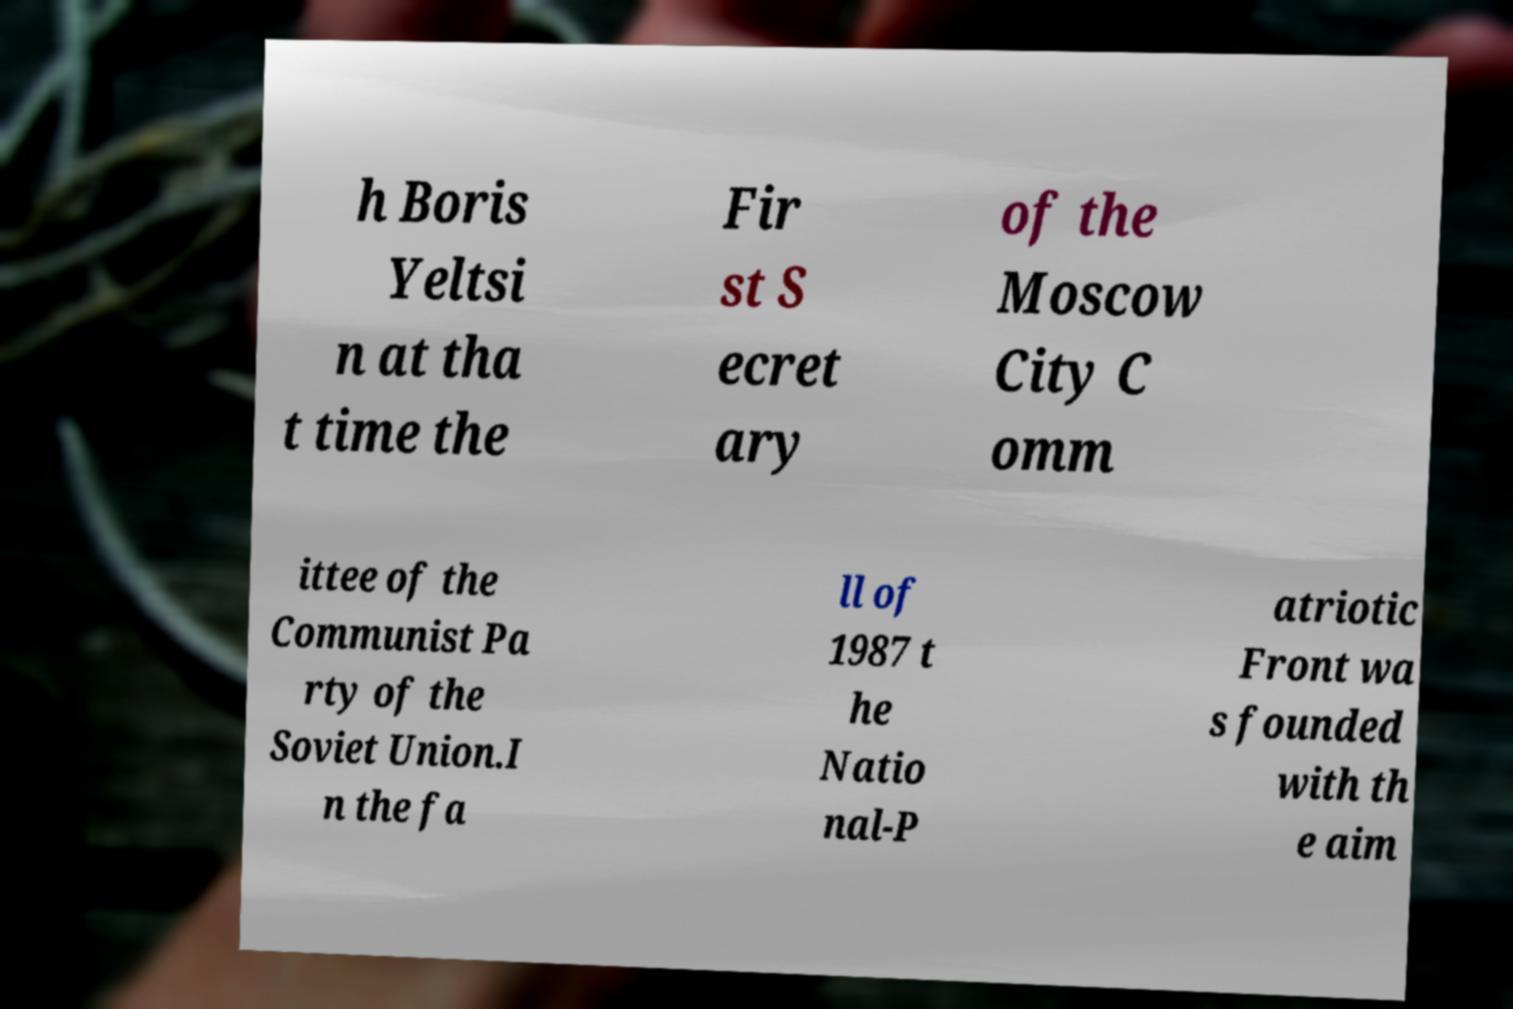What messages or text are displayed in this image? I need them in a readable, typed format. h Boris Yeltsi n at tha t time the Fir st S ecret ary of the Moscow City C omm ittee of the Communist Pa rty of the Soviet Union.I n the fa ll of 1987 t he Natio nal-P atriotic Front wa s founded with th e aim 